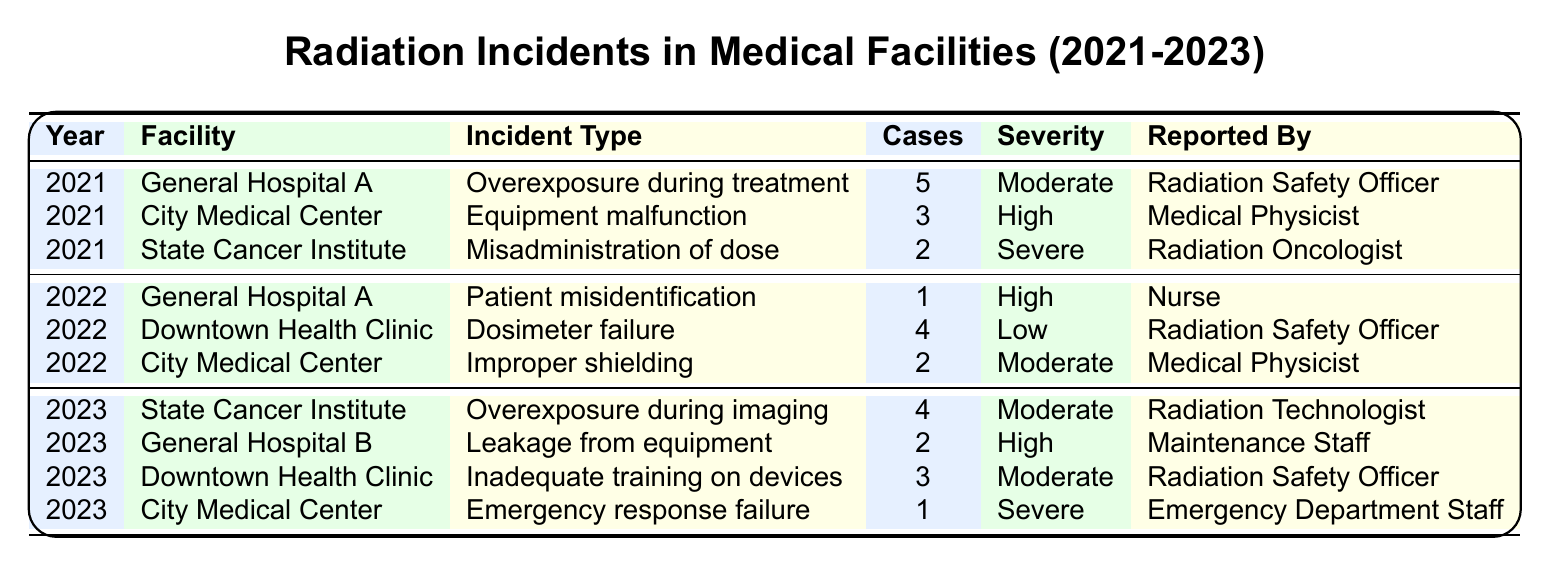What is the total number of radiation incidents reported in 2021? The table lists three incidents for the year 2021: General Hospital A (5 cases), City Medical Center (3 cases), and State Cancer Institute (2 cases). Adding these together gives 5 + 3 + 2 = 10 incidents for the year 2021.
Answer: 10 Which facility reported the highest number of cases in 2021? In 2021, General Hospital A reported 5 cases, City Medical Center reported 3 cases, and State Cancer Institute reported 2 cases. The highest number of cases is from General Hospital A with 5 cases.
Answer: General Hospital A What was the incident with the highest severity reported in 2022? The incidents reported in 2022 were: General Hospital A (High severity), Downtown Health Clinic (Low severity), and City Medical Center (Moderate severity). The highest severity is High, present in the incident at General Hospital A.
Answer: General Hospital A How many incidents were reported in 2023? The table shows four incidents reported in 2023: State Cancer Institute (4 cases), General Hospital B (2 cases), Downtown Health Clinic (3 cases), and City Medical Center (1 case). Adding these together gives 4 + 2 + 3 + 1 = 10 incidents for the year 2023.
Answer: 10 What is the average number of cases reported per year from 2021 to 2023? Adding all cases from 2021 (10), 2022 (7), and 2023 (10), we get a total of 10 + 7 + 10 = 27 cases over three years. Dividing the total by the number of years, we get 27 / 3 = 9 cases on average.
Answer: 9 Is there any incident reported in 2022 that involves a failure of equipment? The incidents in 2022 include General Hospital A (patient misidentification), Downtown Health Clinic (dosimeter failure), and City Medical Center (improper shielding). Since there is a dosimeter failure reported at Downtown Health Clinic, the answer is yes.
Answer: Yes Which year had the least number of incidents overall? Counting the incidents: 2021 had 3, 2022 had 3, and 2023 had 4 incidents. The years with the least incidents are 2021 and 2022, both having 3 incidents.
Answer: 2021 and 2022 What are the incident types reported in the City Medical Center? The table lists incidents from City Medical Center in 2021 (equipment malfunction), 2022 (improper shielding), and 2023 (emergency response failure). Therefore, the incident types are equipment malfunction, improper shielding, and emergency response failure.
Answer: Equipment malfunction, Improper shielding, Emergency response failure How many incidents involved the reporting by a Radiation Safety Officer across all years? The table shows incidents reported by a Radiation Safety Officer in 2021 (1 incident), 2022 (4 incidents), and 2023 (3 incidents). Therefore, the total is 1 + 4 + 3 = 8 incidents reported by a Radiation Safety Officer.
Answer: 8 What is the percentage of high severity incidents among all reported incidents from 2021 to 2023? From the table, there are 2 high severity incidents: one in 2021 (City Medical Center) and one in 2023 (General Hospital B). The total number of incidents across all years is 27. The percentage is (2/27) * 100, which equals approximately 7.41%.
Answer: Approximately 7.41% 